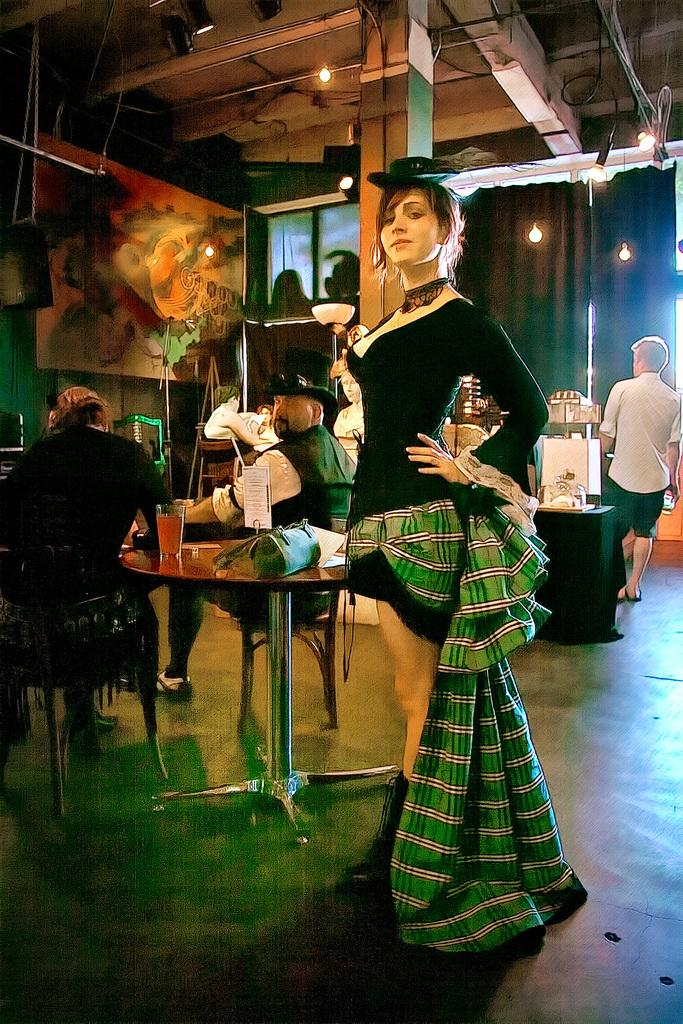What is the main subject of the image? The main subject of the image is a group of people. What can be seen on the table in the image? There is a bag and a glass on the table in the image. What are some of the people in the image doing? Some persons are sitting on chairs, while others are standing. Can you see any cobwebs in the image? There is no mention of cobwebs in the provided facts, so we cannot determine if any are present in the image. --- 